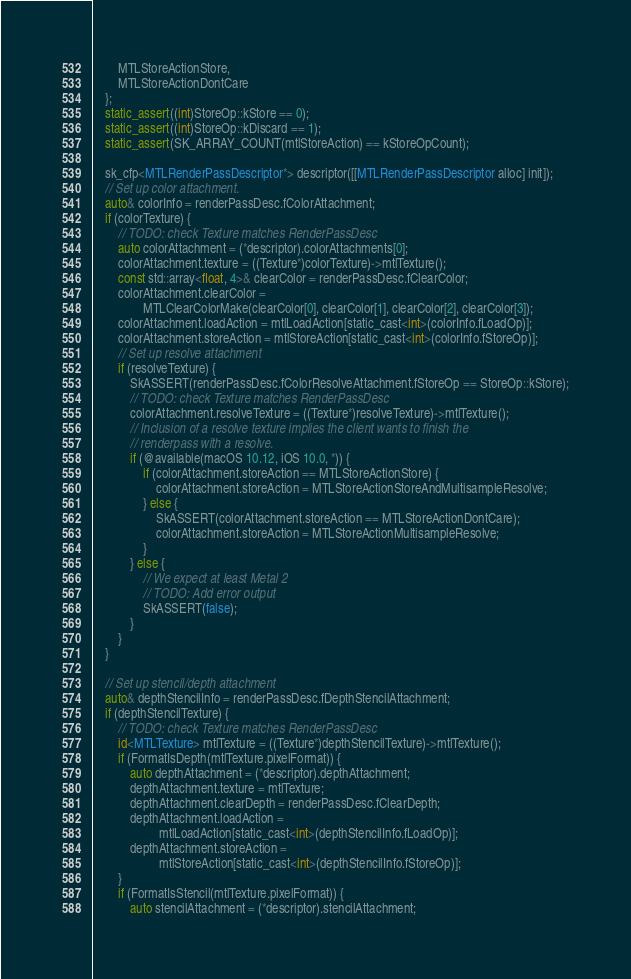<code> <loc_0><loc_0><loc_500><loc_500><_ObjectiveC_>        MTLStoreActionStore,
        MTLStoreActionDontCare
    };
    static_assert((int)StoreOp::kStore == 0);
    static_assert((int)StoreOp::kDiscard == 1);
    static_assert(SK_ARRAY_COUNT(mtlStoreAction) == kStoreOpCount);

    sk_cfp<MTLRenderPassDescriptor*> descriptor([[MTLRenderPassDescriptor alloc] init]);
    // Set up color attachment.
    auto& colorInfo = renderPassDesc.fColorAttachment;
    if (colorTexture) {
        // TODO: check Texture matches RenderPassDesc
        auto colorAttachment = (*descriptor).colorAttachments[0];
        colorAttachment.texture = ((Texture*)colorTexture)->mtlTexture();
        const std::array<float, 4>& clearColor = renderPassDesc.fClearColor;
        colorAttachment.clearColor =
                MTLClearColorMake(clearColor[0], clearColor[1], clearColor[2], clearColor[3]);
        colorAttachment.loadAction = mtlLoadAction[static_cast<int>(colorInfo.fLoadOp)];
        colorAttachment.storeAction = mtlStoreAction[static_cast<int>(colorInfo.fStoreOp)];
        // Set up resolve attachment
        if (resolveTexture) {
            SkASSERT(renderPassDesc.fColorResolveAttachment.fStoreOp == StoreOp::kStore);
            // TODO: check Texture matches RenderPassDesc
            colorAttachment.resolveTexture = ((Texture*)resolveTexture)->mtlTexture();
            // Inclusion of a resolve texture implies the client wants to finish the
            // renderpass with a resolve.
            if (@available(macOS 10.12, iOS 10.0, *)) {
                if (colorAttachment.storeAction == MTLStoreActionStore) {
                    colorAttachment.storeAction = MTLStoreActionStoreAndMultisampleResolve;
                } else {
                    SkASSERT(colorAttachment.storeAction == MTLStoreActionDontCare);
                    colorAttachment.storeAction = MTLStoreActionMultisampleResolve;
                }
            } else {
                // We expect at least Metal 2
                // TODO: Add error output
                SkASSERT(false);
            }
        }
    }

    // Set up stencil/depth attachment
    auto& depthStencilInfo = renderPassDesc.fDepthStencilAttachment;
    if (depthStencilTexture) {
        // TODO: check Texture matches RenderPassDesc
        id<MTLTexture> mtlTexture = ((Texture*)depthStencilTexture)->mtlTexture();
        if (FormatIsDepth(mtlTexture.pixelFormat)) {
            auto depthAttachment = (*descriptor).depthAttachment;
            depthAttachment.texture = mtlTexture;
            depthAttachment.clearDepth = renderPassDesc.fClearDepth;
            depthAttachment.loadAction =
                     mtlLoadAction[static_cast<int>(depthStencilInfo.fLoadOp)];
            depthAttachment.storeAction =
                     mtlStoreAction[static_cast<int>(depthStencilInfo.fStoreOp)];
        }
        if (FormatIsStencil(mtlTexture.pixelFormat)) {
            auto stencilAttachment = (*descriptor).stencilAttachment;</code> 